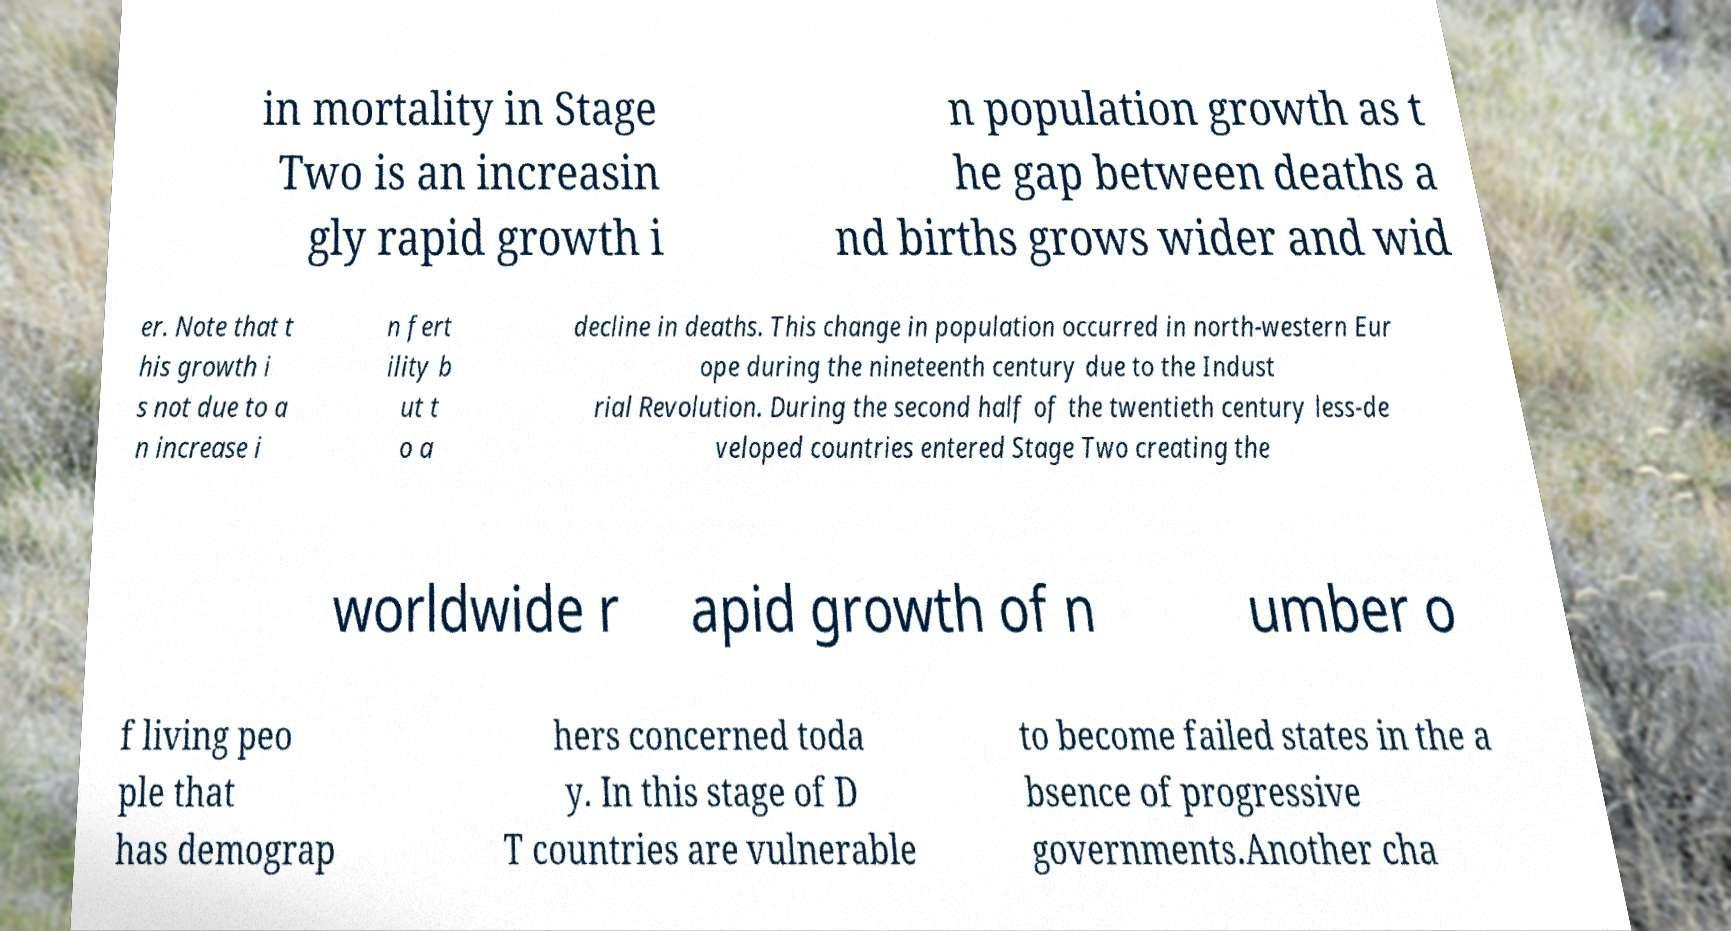Can you read and provide the text displayed in the image?This photo seems to have some interesting text. Can you extract and type it out for me? in mortality in Stage Two is an increasin gly rapid growth i n population growth as t he gap between deaths a nd births grows wider and wid er. Note that t his growth i s not due to a n increase i n fert ility b ut t o a decline in deaths. This change in population occurred in north-western Eur ope during the nineteenth century due to the Indust rial Revolution. During the second half of the twentieth century less-de veloped countries entered Stage Two creating the worldwide r apid growth of n umber o f living peo ple that has demograp hers concerned toda y. In this stage of D T countries are vulnerable to become failed states in the a bsence of progressive governments.Another cha 